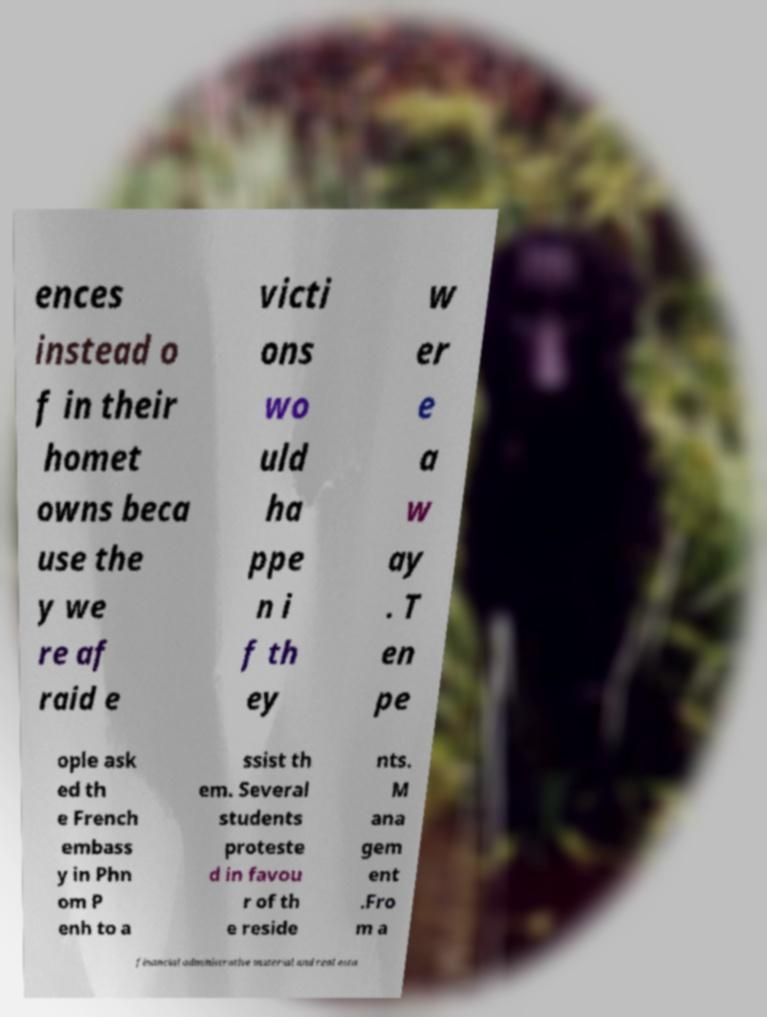I need the written content from this picture converted into text. Can you do that? ences instead o f in their homet owns beca use the y we re af raid e victi ons wo uld ha ppe n i f th ey w er e a w ay . T en pe ople ask ed th e French embass y in Phn om P enh to a ssist th em. Several students proteste d in favou r of th e reside nts. M ana gem ent .Fro m a financial administrative material and real esta 